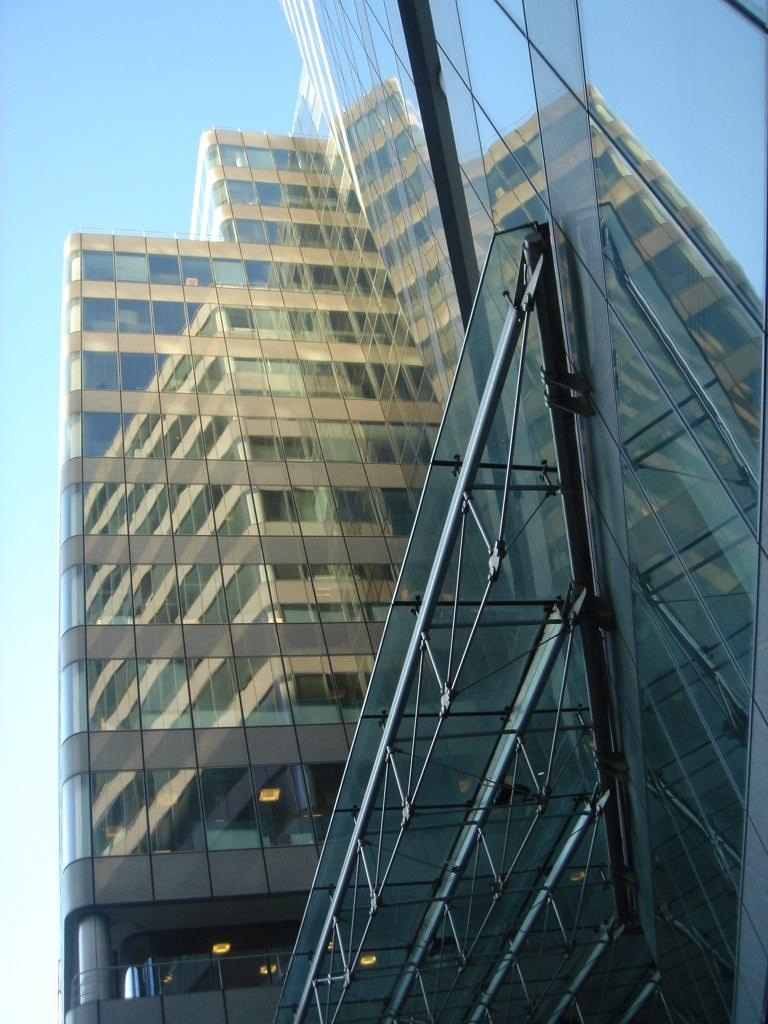What type of structure is present in the image? There is a building in the image. What part of the natural environment is visible in the image? The sky is visible in the top left corner of the image. What type of leather is being used by the judge in the image? There is no judge or leather present in the image; it only features a building and the sky. 